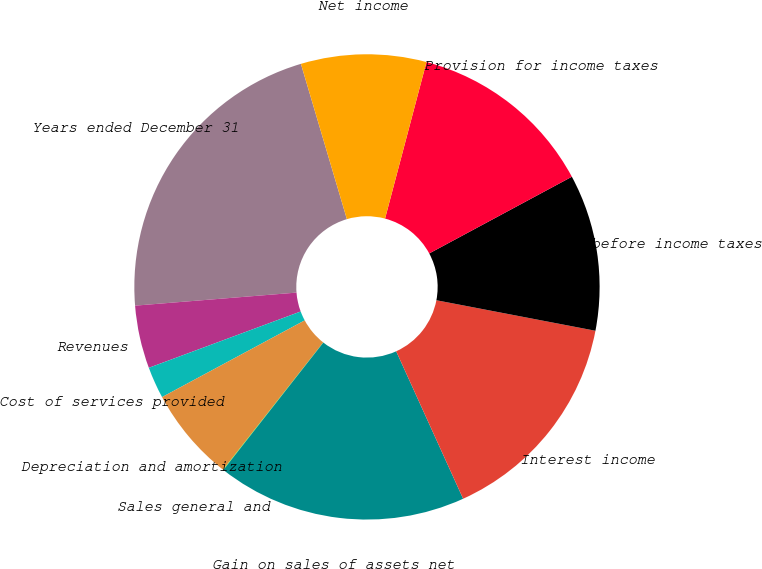Convert chart to OTSL. <chart><loc_0><loc_0><loc_500><loc_500><pie_chart><fcel>Years ended December 31<fcel>Revenues<fcel>Cost of services provided<fcel>Depreciation and amortization<fcel>Sales general and<fcel>Gain on sales of assets net<fcel>Interest income<fcel>Income before income taxes<fcel>Provision for income taxes<fcel>Net income<nl><fcel>21.7%<fcel>4.37%<fcel>2.2%<fcel>6.53%<fcel>0.03%<fcel>17.37%<fcel>15.2%<fcel>10.87%<fcel>13.03%<fcel>8.7%<nl></chart> 